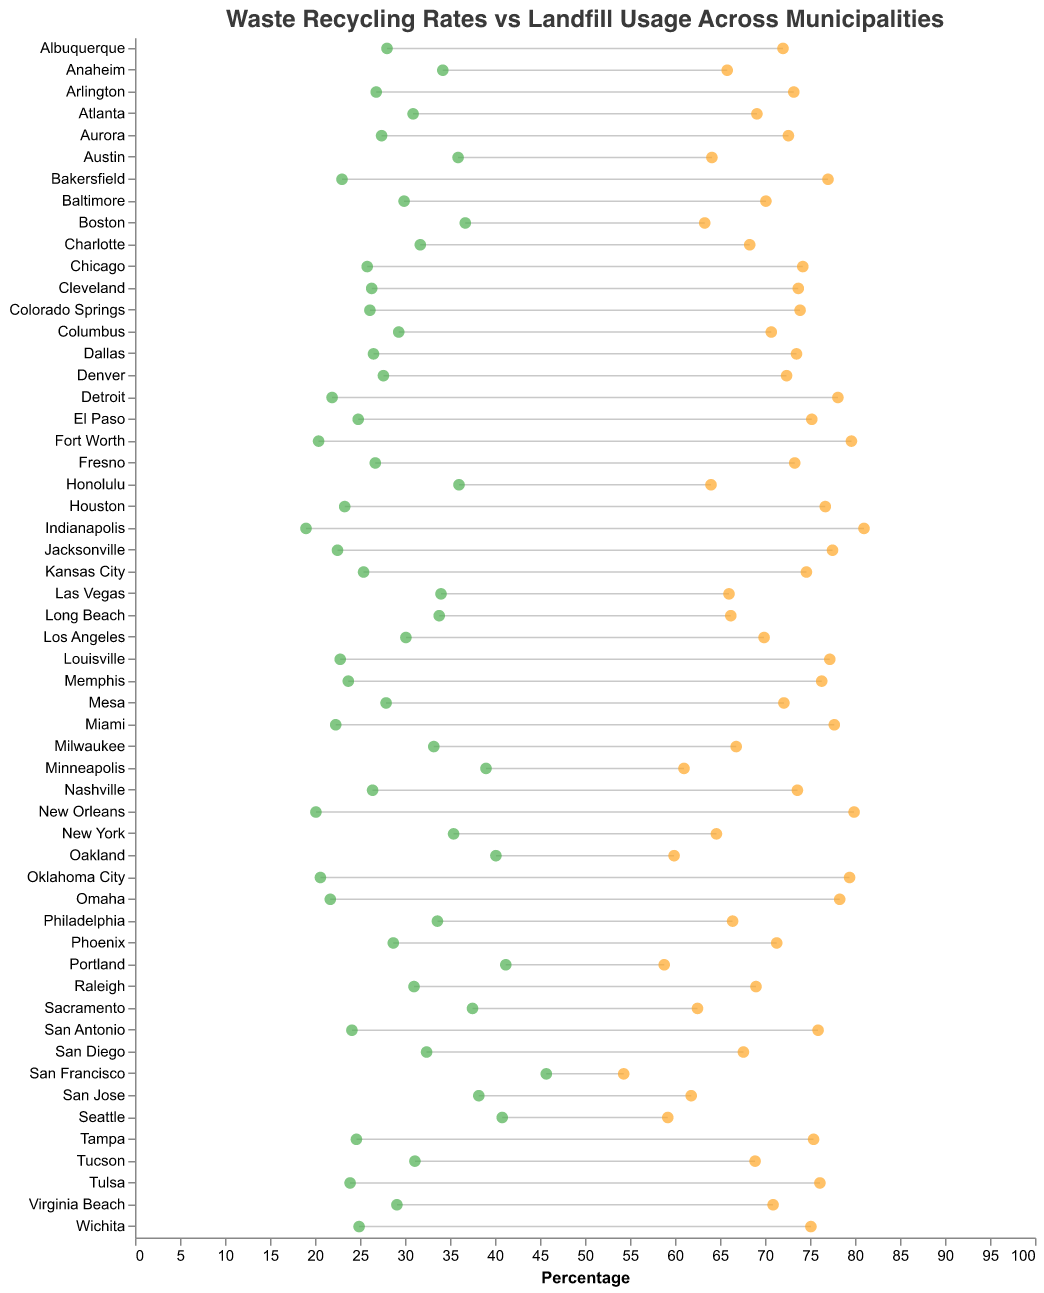What is the title of the plot? The title of the plot is usually displayed at the top of the chart. In this case, it reads, "Waste Recycling Rates vs Landfill Usage Across Municipalities."
Answer: "Waste Recycling Rates vs Landfill Usage Across Municipalities" How many municipalities are represented in the plot? Count the distinct names of the municipalities listed on the y-axis. There are 50 municipalities displayed.
Answer: 50 Which municipality has the highest recycling rate? Locate the green circle representing the highest recycling rate. It points to "San Francisco," which has a recycling rate of 45.7%.
Answer: San Francisco Which municipality has the lowest landfill usage? Identify the lowest orange circle value on the x-axis. It points to "San Francisco" with 54.3%, making it the lowest landfill usage.
Answer: San Francisco How is landfill usage represented in the plot? The landfill usage is indicated by the orange circles on the right side. These circles are connected with the green circles by a line to show the contrast between recycling rates and landfill usage for each municipality.
Answer: By orange circles connected with lines Which municipality has the smallest difference between recycling rate and landfill usage? Calculate the differences between the green and orange circles for each municipality. The smallest difference is for "San Francisco," as 45.7% (recycling) and 54.3% (landfill) have a difference of 8.6%.
Answer: San Francisco Which municipality has the highest landfill usage rate? Identify the municipality with the highest position on the x-axis for the orange circle. The highest landfill usage rate is "Indianapolis" at 81.0%.
Answer: Indianapolis How many municipalities have a recycling rate above 40%? Count the green circles positioned above the 40% mark on the x-axis. There are 5 municipalities: San Francisco, Seattle, Portland, Oakland, and Minneapolis.
Answer: 5 What is the average recycling rate for Austin and Boston? Identify the recycling rates for Austin (35.9%) and Boston (36.7%). Calculate the average by adding these two rates and dividing by 2: (35.9 + 36.7) / 2 = 36.3%.
Answer: 36.3% Which municipalities have a recycling rate of 30% or higher but less than 35%? Find the green circles between the 30% and 35% marks on the x-axis. These municipalities are Las Vegas (34.0%), Anaheim (34.2%), Philadelphia (33.6%), Los Angeles (30.1%), and Tucson (31.1%).
Answer: Las Vegas, Anaheim, Philadelphia, Los Angeles, Tucson 